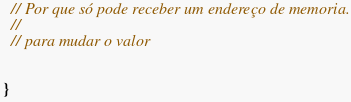Convert code to text. <code><loc_0><loc_0><loc_500><loc_500><_C_>  // Por que só pode receber um endereço de memoria.
  //
  // para mudar o valor


}
</code> 